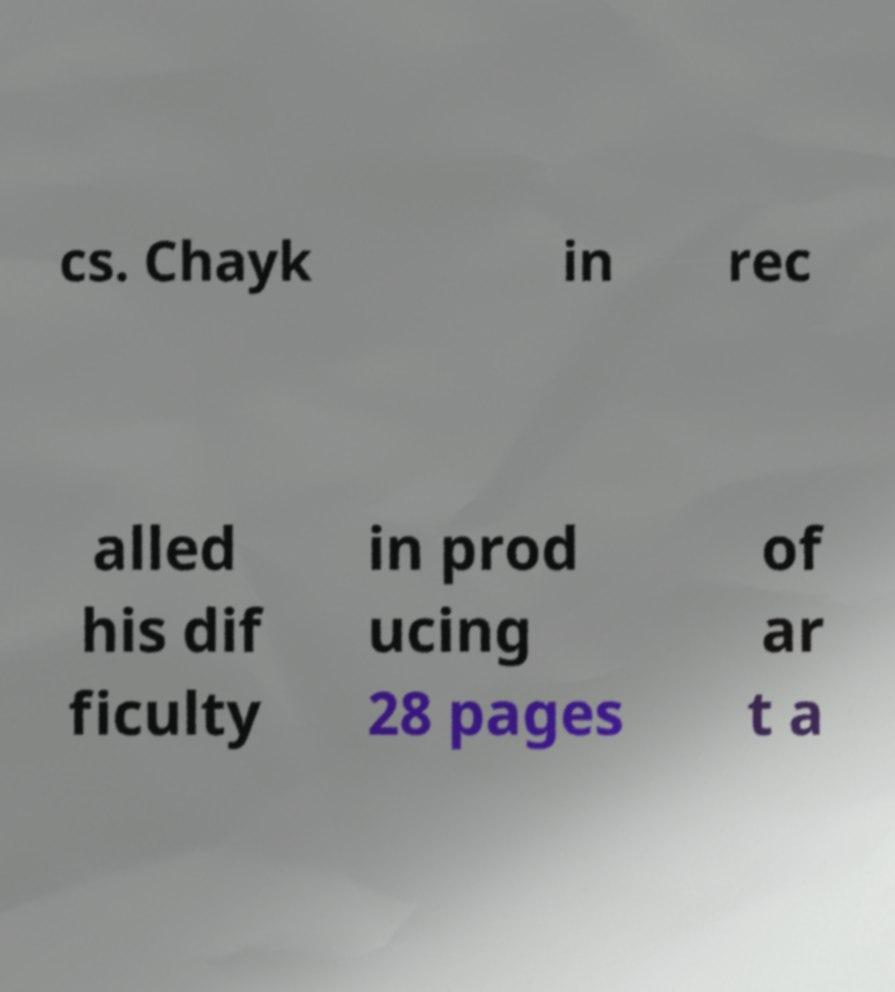Please read and relay the text visible in this image. What does it say? cs. Chayk in rec alled his dif ficulty in prod ucing 28 pages of ar t a 